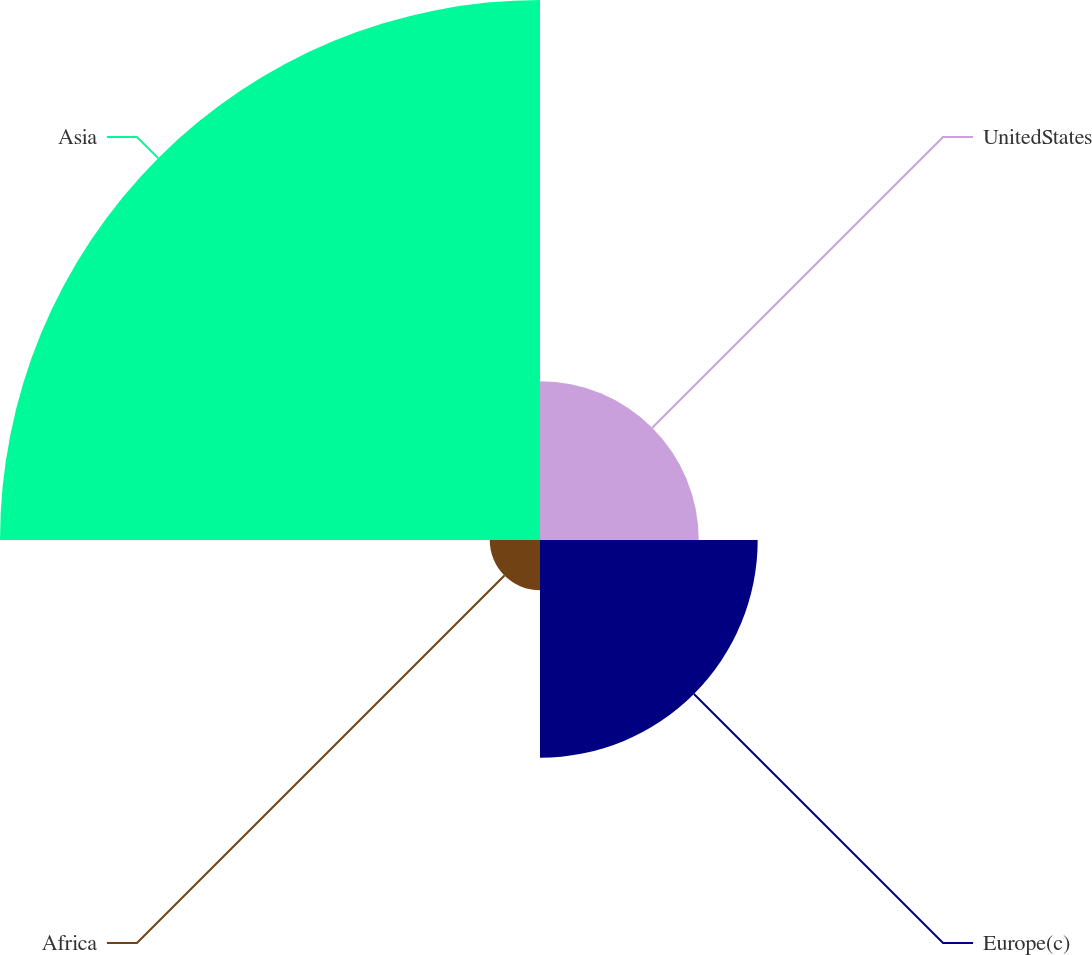<chart> <loc_0><loc_0><loc_500><loc_500><pie_chart><fcel>UnitedStates<fcel>Europe(c)<fcel>Africa<fcel>Asia<nl><fcel>16.42%<fcel>22.52%<fcel>5.2%<fcel>55.86%<nl></chart> 